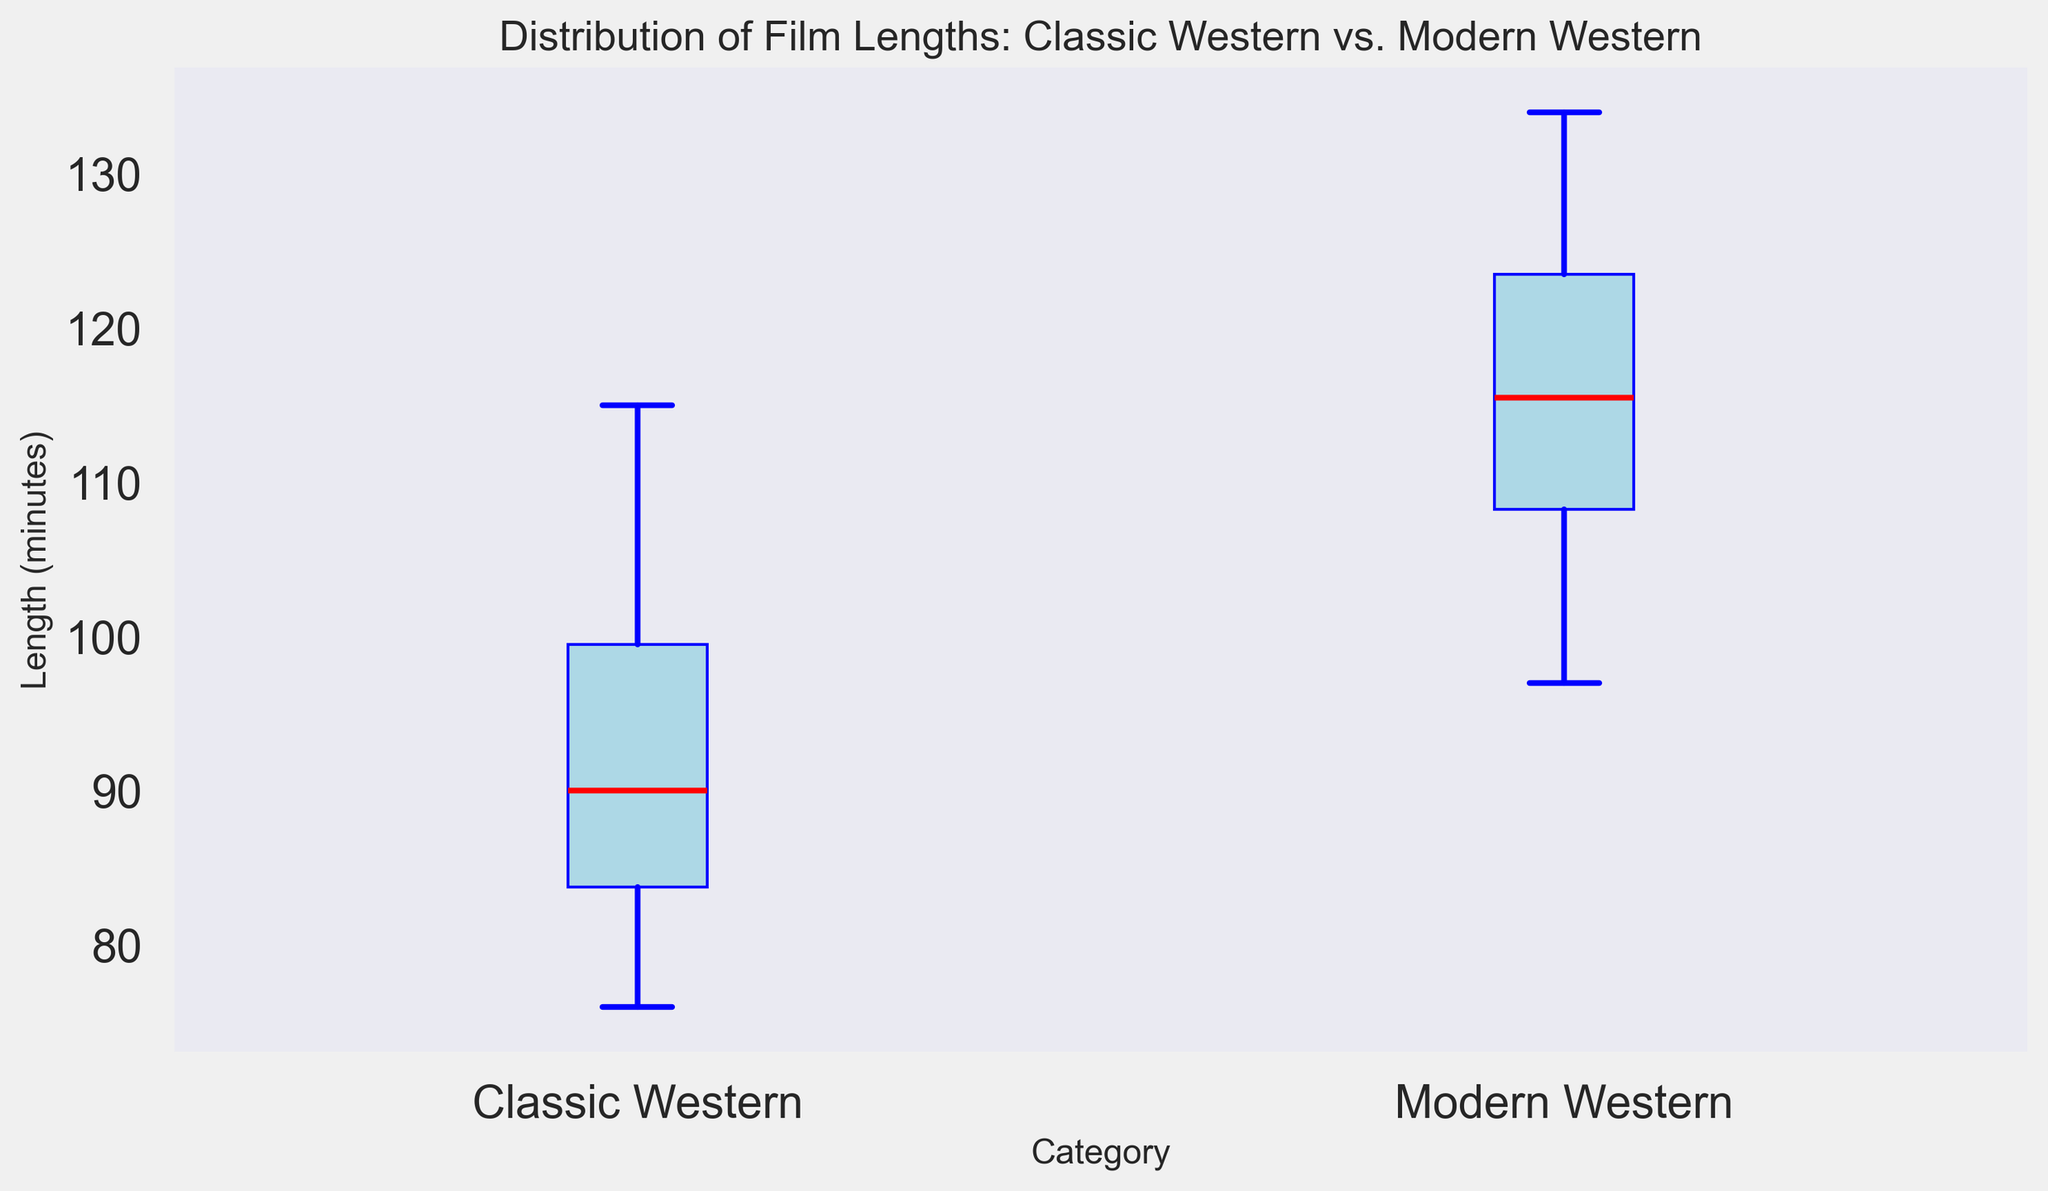What is the median film length for classic Western movies? To find the median of the classic Western movies' film lengths, locate the center value in the sorted list of their lengths. These values are: 76, 78, 79, 80, 82, 83, 84, 85, 86, 87, 88, 89, 91, 92, 93, 94, 95, 99, 101, 105, 107, 108, 110, 115. With 24 data points, the median is the average of the 12th and 13th values: (89 + 91) / 2 = 90.
Answer: 90 What is the interquartile range (IQR) for modern Western movies? The IQR is the difference between the first quartile (Q1) and the third quartile (Q3). From the boxplot, find Q1 and Q3 for modern Western movies by locating the lower and upper edges of the box, respectively. Let's assume Q1=104 and Q3=120 in the figure; hence the IQR = 120 - 104 = 16.
Answer: 16 Which category has a wider range of film lengths? Compare the lengths of the whiskers (from the minimum to maximum values) for both categories. In the figure, if modern Western movies show a wider spread between their minimum and maximum lengths than classic Western movies, then modern Western movies have a wider range.
Answer: Modern Western Between classic Western and modern Western movies, which category has the higher median film length? Locate the median line within the boxes for both categories. If the median line for modern Western movies is higher than that for classic Western movies, modern Western movies have a higher median film length.
Answer: Modern Western Are there any outliers in the classic Western movie lengths? Outliers are indicated by points beyond the whiskers in the box plot. Check if there are individual points outside the whiskers in the box plot for classic Western movies. If none are present, there are no outliers.
Answer: No What is the difference between the maximum film lengths of classic Western and modern Western movies? Identify the maximum points for both categories from the box plot. Let's assume the maximum for classic Westerns is 115 and for modern Westerns it is 134. Calculate the difference: 134 - 115 = 19.
Answer: 19 Which category has the lower 25th percentile of film lengths? The 25th percentile (Q1) is the bottom edge of the box. Compare this edge for both categories. If Q1 is lower for classic Western movies than for modern Western movies, then classic Western movies have the lower 25th percentile.
Answer: Classic Western What is the median film length difference between classic Western and modern Western movies? Determine the medians from the plot. Let's assume the median for classic Westerns is 90 and for modern Westerns is 110. The difference is 110 - 90 = 20.
Answer: 20 